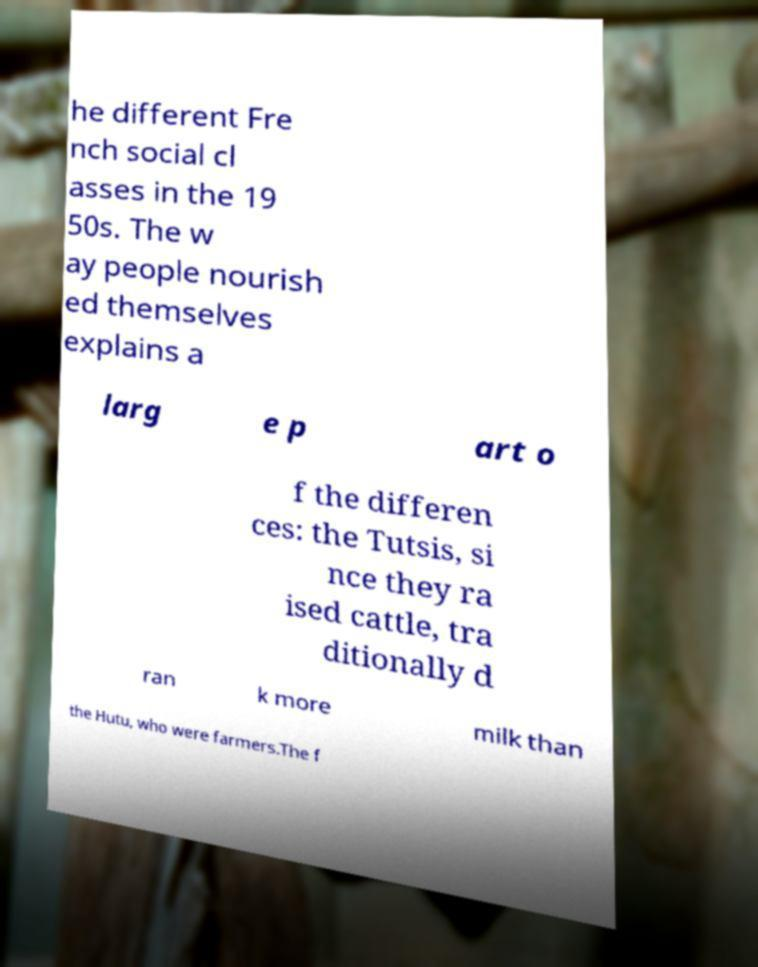Please read and relay the text visible in this image. What does it say? he different Fre nch social cl asses in the 19 50s. The w ay people nourish ed themselves explains a larg e p art o f the differen ces: the Tutsis, si nce they ra ised cattle, tra ditionally d ran k more milk than the Hutu, who were farmers.The f 